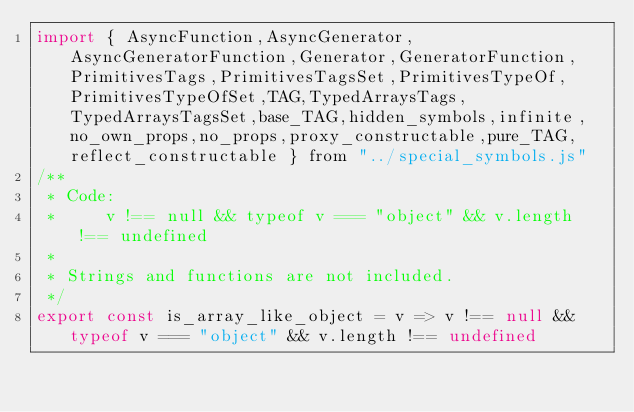Convert code to text. <code><loc_0><loc_0><loc_500><loc_500><_JavaScript_>import { AsyncFunction,AsyncGenerator,AsyncGeneratorFunction,Generator,GeneratorFunction,PrimitivesTags,PrimitivesTagsSet,PrimitivesTypeOf,PrimitivesTypeOfSet,TAG,TypedArraysTags,TypedArraysTagsSet,base_TAG,hidden_symbols,infinite,no_own_props,no_props,proxy_constructable,pure_TAG,reflect_constructable } from "../special_symbols.js"
/**
 * Code:
 *     v !== null && typeof v === "object" && v.length !== undefined 
 *
 * Strings and functions are not included.
 */
export const is_array_like_object = v => v !== null && typeof v === "object" && v.length !== undefined 
</code> 